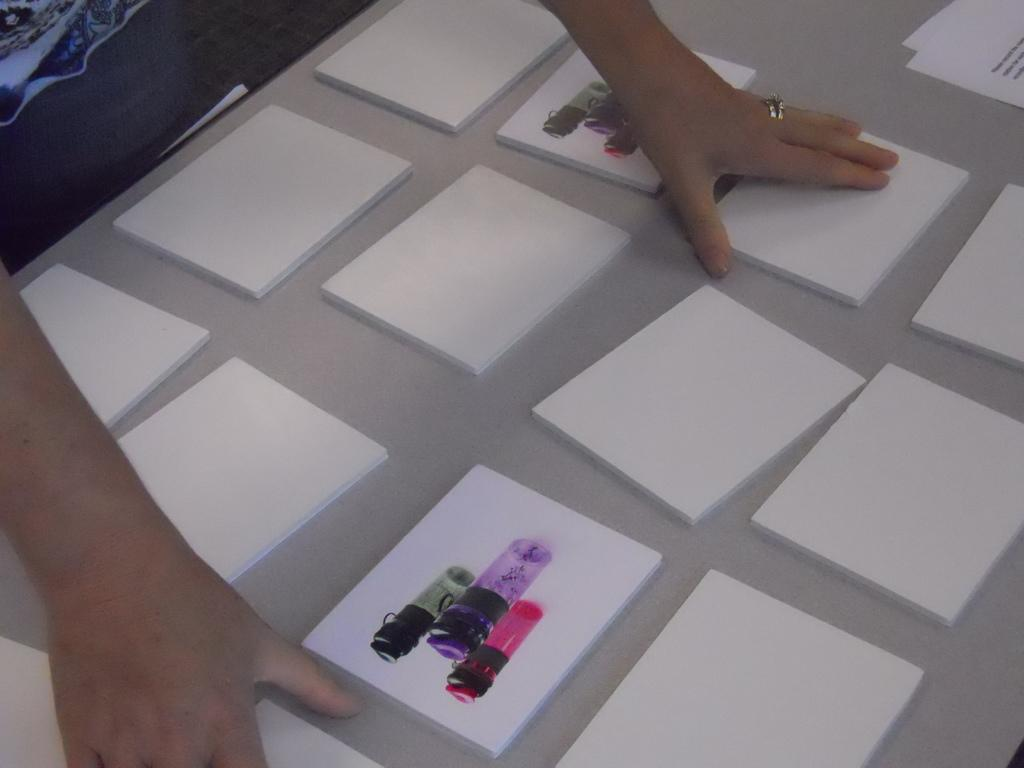What is the main subject of the image? There is a person in the image. What objects are on the table in the image? There are paper cardboards on the table. What is depicted on the paper cardboards? There is a picture of 3 bottles on the 2 paper cardboards. How many clocks are visible in the image? There are no clocks visible in the image. Can you describe the goose that is sitting on the table in the image? There is no goose present in the image. 